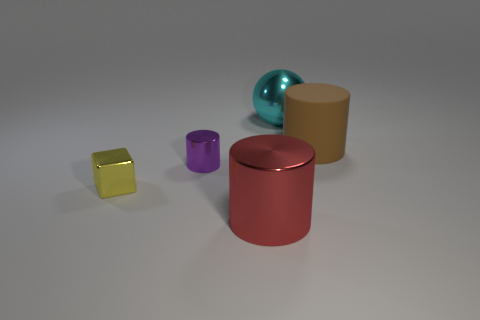Add 3 tiny purple objects. How many objects exist? 8 Subtract all shiny cylinders. How many cylinders are left? 1 Subtract all balls. How many objects are left? 4 Subtract all gray cylinders. Subtract all red balls. How many cylinders are left? 3 Subtract all purple things. Subtract all cyan objects. How many objects are left? 3 Add 2 brown objects. How many brown objects are left? 3 Add 1 large spheres. How many large spheres exist? 2 Subtract 0 cyan cylinders. How many objects are left? 5 